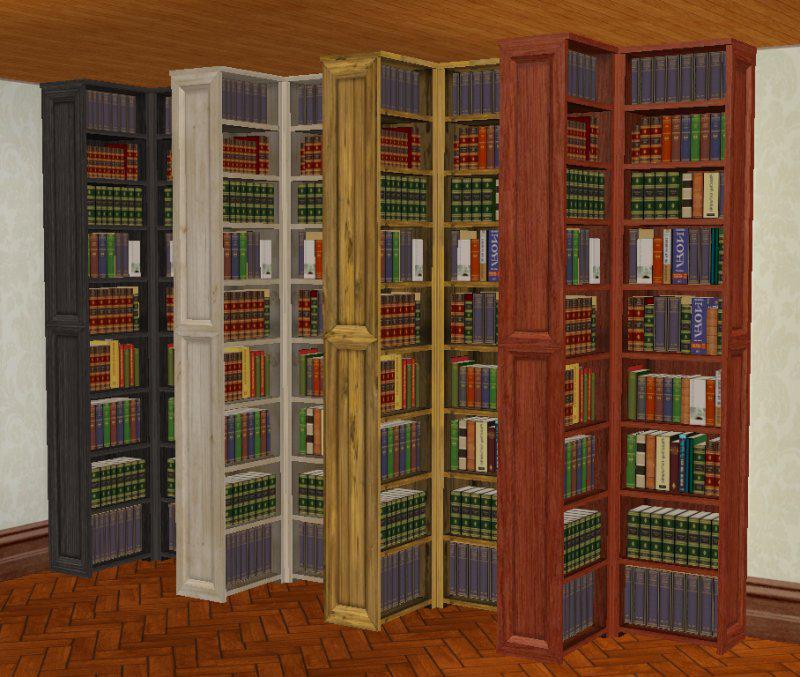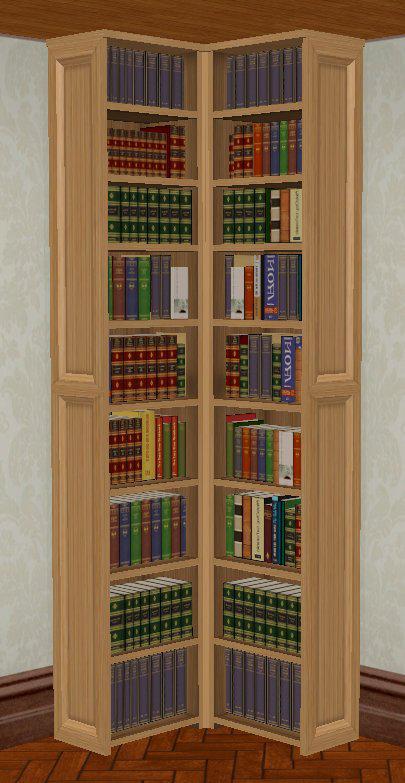The first image is the image on the left, the second image is the image on the right. Analyze the images presented: Is the assertion "There is a desk in front of the bookcases in one of the images." valid? Answer yes or no. No. 